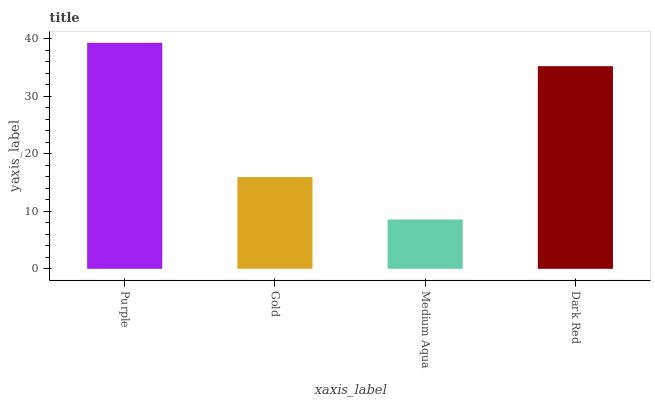Is Medium Aqua the minimum?
Answer yes or no. Yes. Is Purple the maximum?
Answer yes or no. Yes. Is Gold the minimum?
Answer yes or no. No. Is Gold the maximum?
Answer yes or no. No. Is Purple greater than Gold?
Answer yes or no. Yes. Is Gold less than Purple?
Answer yes or no. Yes. Is Gold greater than Purple?
Answer yes or no. No. Is Purple less than Gold?
Answer yes or no. No. Is Dark Red the high median?
Answer yes or no. Yes. Is Gold the low median?
Answer yes or no. Yes. Is Gold the high median?
Answer yes or no. No. Is Medium Aqua the low median?
Answer yes or no. No. 